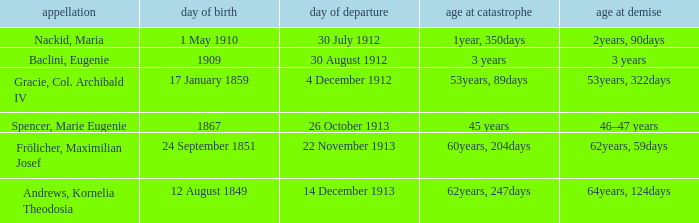When did the person born 24 September 1851 pass away? 22 November 1913. 